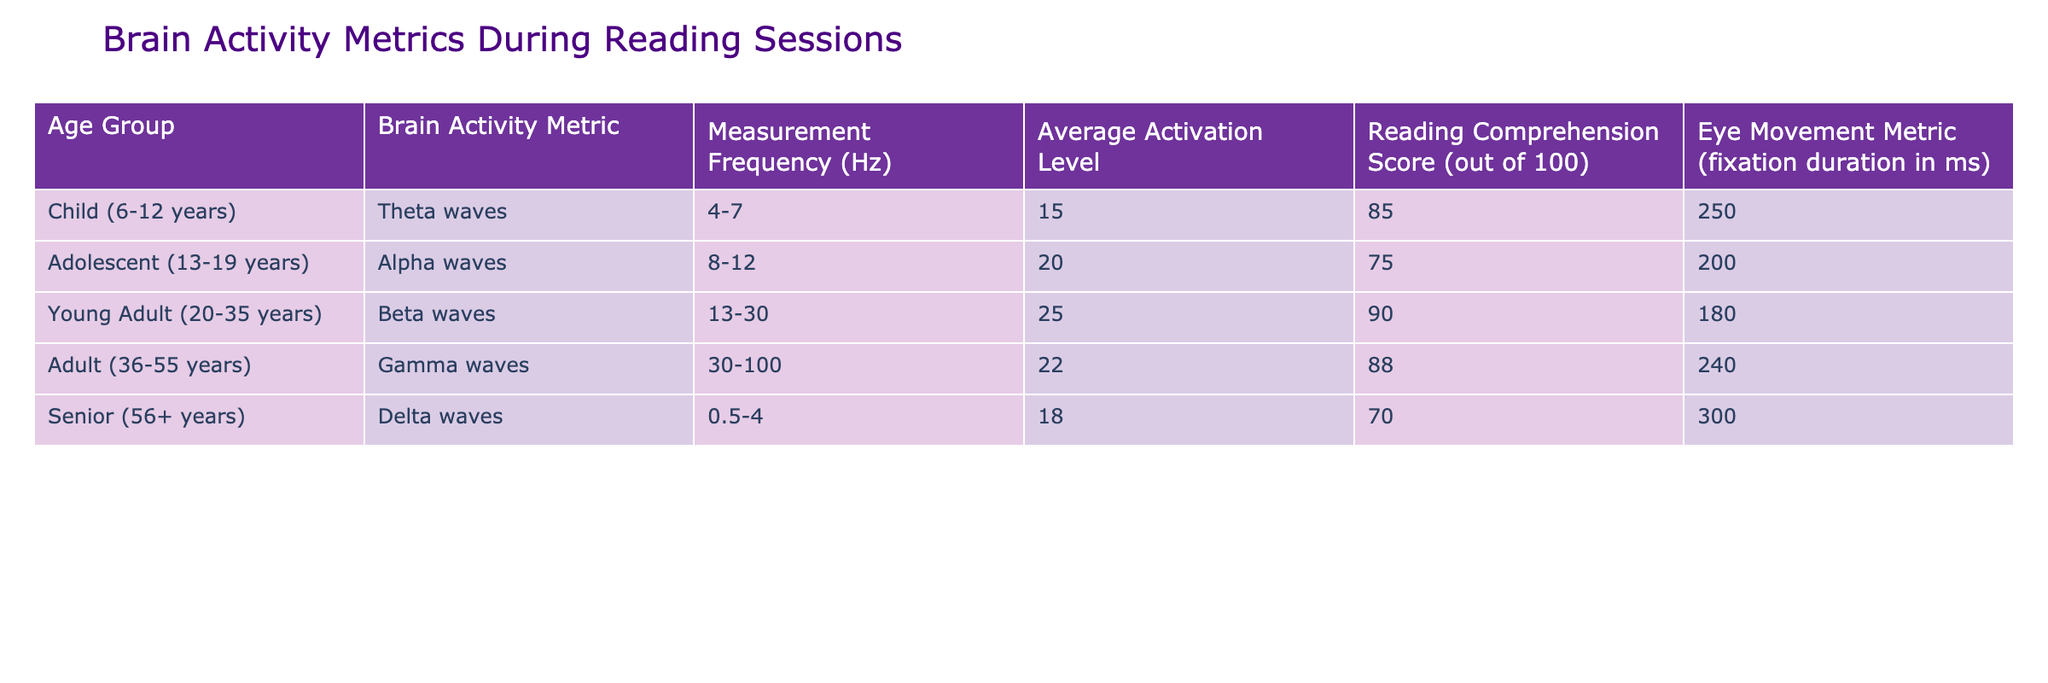What brain activity metric is observed in young adults? According to the table, the brain activity metric for young adults (ages 20-35 years) is beta waves.
Answer: Beta waves What is the average activation level for children during reading sessions? The table indicates that the average activation level for the child age group (6-12 years) is 15.
Answer: 15 Do seniors exhibit a higher reading comprehension score than adolescents? The reading comprehension score for seniors (70) is lower than that for adolescents (75), so the statement is false.
Answer: No What is the difference in average activation levels between adolescents and seniors? From the table, the average activation level for adolescents is 20 and for seniors is 18. The difference is 20 - 18 = 2.
Answer: 2 Is the measurement frequency for theta waves higher than that for delta waves? The measurement frequency for theta waves is 4-7 Hz, while for delta waves it is 0.5-4 Hz. Since 4-7 Hz is higher, the statement is true.
Answer: Yes Calculate the average reading comprehension score for all age groups. The scores are as follows: 85 (children) + 75 (adolescents) + 90 (young adults) + 88 (adults) + 70 (seniors). Total = 85 + 75 + 90 + 88 + 70 = 408. There are 5 age groups, so the average is 408 / 5 = 81.6.
Answer: 81.6 Which age group has the longest average fixation duration? The table shows that seniors have an eye movement metric (fixation duration) of 300 ms, which is higher than all other groups.
Answer: Seniors Are the brain activity metrics the same for all age groups? No, each age group has a different brain activity metric, as indicated in the table.
Answer: No What is the average reading comprehension score for adults compared to young adults? The reading comprehension score for adults is 88, while for young adults it is 90. Young adults have a higher score by 2 points.
Answer: Young adults by 2 points 